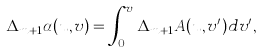Convert formula to latex. <formula><loc_0><loc_0><loc_500><loc_500>\Delta _ { m + 1 } \alpha ( u , v ) = \int _ { 0 } ^ { v } \Delta _ { m + 1 } A ( u , v ^ { \prime } ) d v ^ { \prime } ,</formula> 